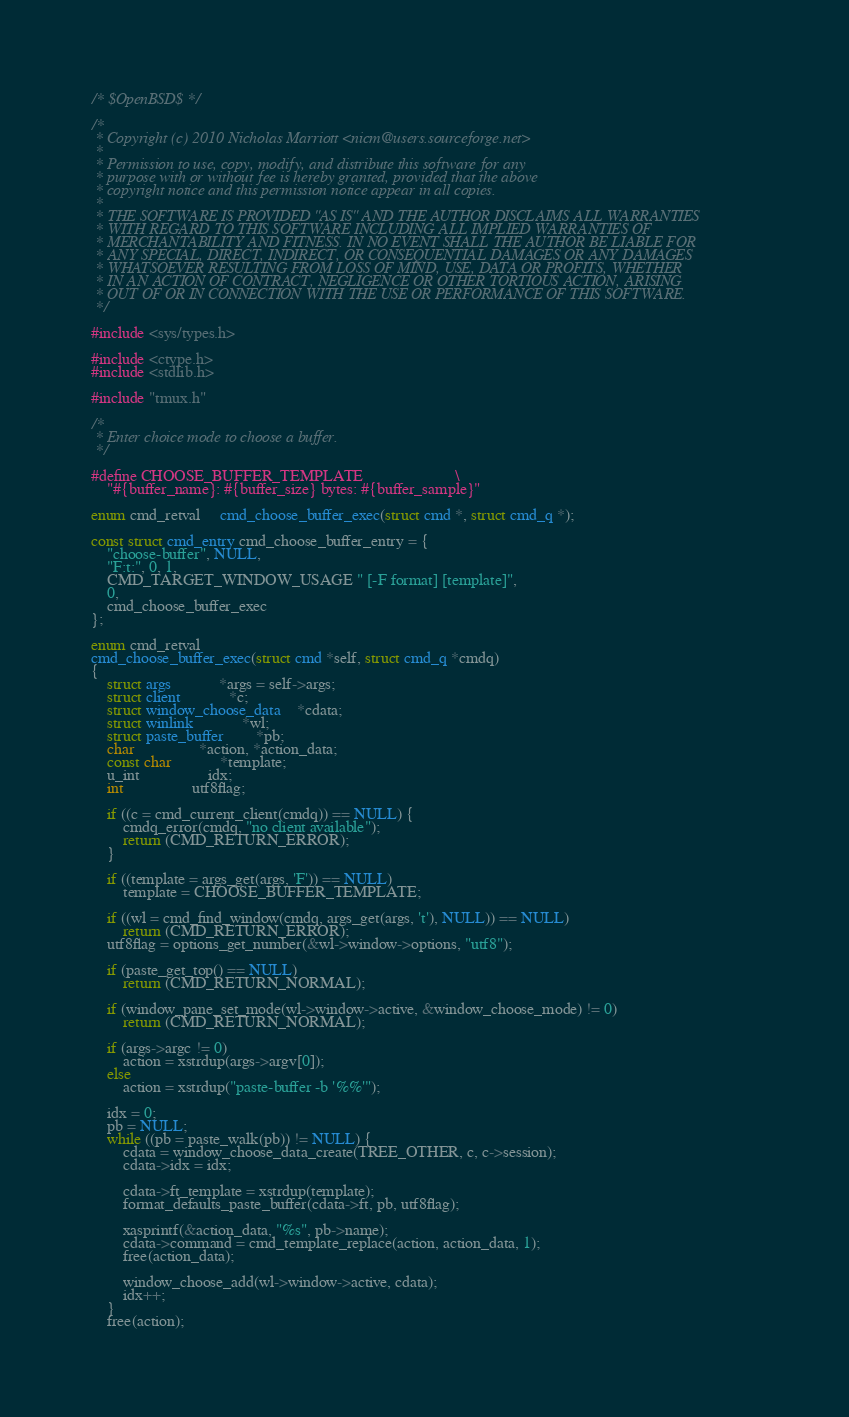<code> <loc_0><loc_0><loc_500><loc_500><_C_>/* $OpenBSD$ */

/*
 * Copyright (c) 2010 Nicholas Marriott <nicm@users.sourceforge.net>
 *
 * Permission to use, copy, modify, and distribute this software for any
 * purpose with or without fee is hereby granted, provided that the above
 * copyright notice and this permission notice appear in all copies.
 *
 * THE SOFTWARE IS PROVIDED "AS IS" AND THE AUTHOR DISCLAIMS ALL WARRANTIES
 * WITH REGARD TO THIS SOFTWARE INCLUDING ALL IMPLIED WARRANTIES OF
 * MERCHANTABILITY AND FITNESS. IN NO EVENT SHALL THE AUTHOR BE LIABLE FOR
 * ANY SPECIAL, DIRECT, INDIRECT, OR CONSEQUENTIAL DAMAGES OR ANY DAMAGES
 * WHATSOEVER RESULTING FROM LOSS OF MIND, USE, DATA OR PROFITS, WHETHER
 * IN AN ACTION OF CONTRACT, NEGLIGENCE OR OTHER TORTIOUS ACTION, ARISING
 * OUT OF OR IN CONNECTION WITH THE USE OR PERFORMANCE OF THIS SOFTWARE.
 */

#include <sys/types.h>

#include <ctype.h>
#include <stdlib.h>

#include "tmux.h"

/*
 * Enter choice mode to choose a buffer.
 */

#define CHOOSE_BUFFER_TEMPLATE						\
	"#{buffer_name}: #{buffer_size} bytes: #{buffer_sample}"

enum cmd_retval	 cmd_choose_buffer_exec(struct cmd *, struct cmd_q *);

const struct cmd_entry cmd_choose_buffer_entry = {
	"choose-buffer", NULL,
	"F:t:", 0, 1,
	CMD_TARGET_WINDOW_USAGE " [-F format] [template]",
	0,
	cmd_choose_buffer_exec
};

enum cmd_retval
cmd_choose_buffer_exec(struct cmd *self, struct cmd_q *cmdq)
{
	struct args			*args = self->args;
	struct client			*c;
	struct window_choose_data	*cdata;
	struct winlink			*wl;
	struct paste_buffer		*pb;
	char				*action, *action_data;
	const char			*template;
	u_int				 idx;
	int				 utf8flag;

	if ((c = cmd_current_client(cmdq)) == NULL) {
		cmdq_error(cmdq, "no client available");
		return (CMD_RETURN_ERROR);
	}

	if ((template = args_get(args, 'F')) == NULL)
		template = CHOOSE_BUFFER_TEMPLATE;

	if ((wl = cmd_find_window(cmdq, args_get(args, 't'), NULL)) == NULL)
		return (CMD_RETURN_ERROR);
	utf8flag = options_get_number(&wl->window->options, "utf8");

	if (paste_get_top() == NULL)
		return (CMD_RETURN_NORMAL);

	if (window_pane_set_mode(wl->window->active, &window_choose_mode) != 0)
		return (CMD_RETURN_NORMAL);

	if (args->argc != 0)
		action = xstrdup(args->argv[0]);
	else
		action = xstrdup("paste-buffer -b '%%'");

	idx = 0;
	pb = NULL;
	while ((pb = paste_walk(pb)) != NULL) {
		cdata = window_choose_data_create(TREE_OTHER, c, c->session);
		cdata->idx = idx;

		cdata->ft_template = xstrdup(template);
		format_defaults_paste_buffer(cdata->ft, pb, utf8flag);

		xasprintf(&action_data, "%s", pb->name);
		cdata->command = cmd_template_replace(action, action_data, 1);
		free(action_data);

		window_choose_add(wl->window->active, cdata);
		idx++;
	}
	free(action);
</code> 